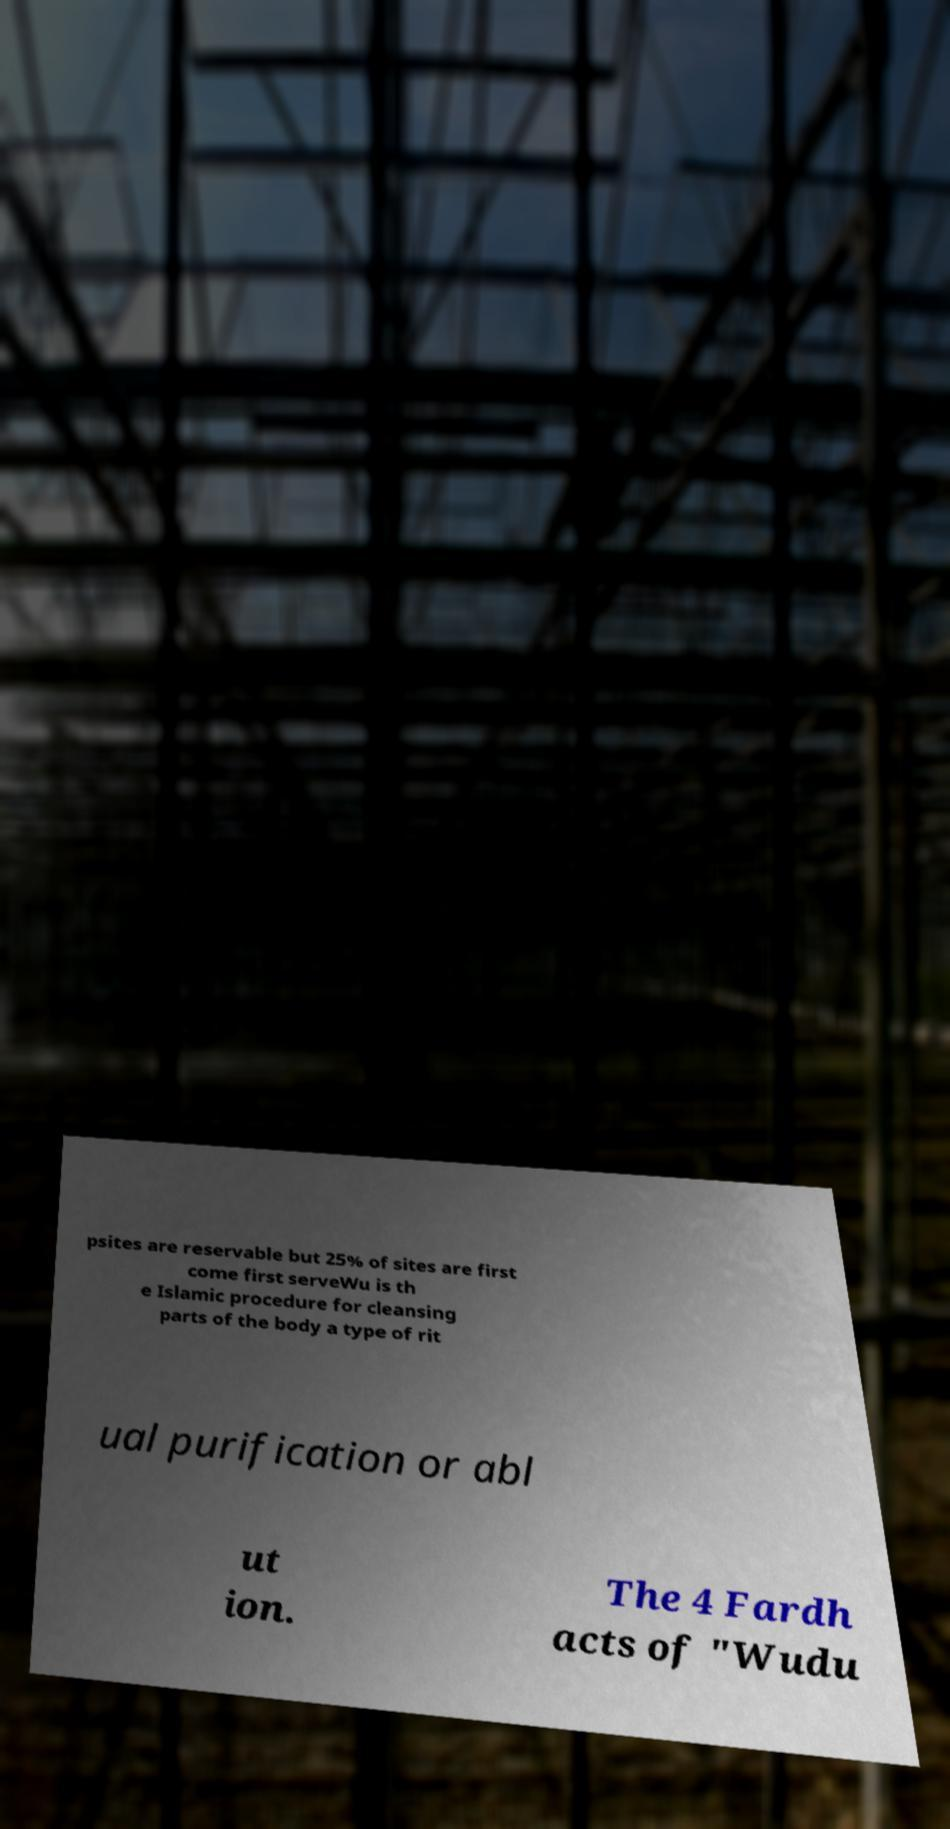For documentation purposes, I need the text within this image transcribed. Could you provide that? psites are reservable but 25% of sites are first come first serveWu is th e Islamic procedure for cleansing parts of the body a type of rit ual purification or abl ut ion. The 4 Fardh acts of "Wudu 